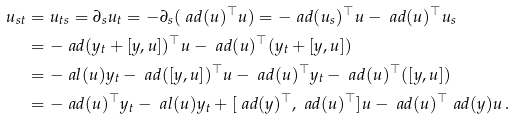<formula> <loc_0><loc_0><loc_500><loc_500>u _ { s t } & = u _ { t s } = \partial _ { s } u _ { t } = - \partial _ { s } ( \ a d ( u ) ^ { \top } u ) = - \ a d ( u _ { s } ) ^ { \top } u - \ a d ( u ) ^ { \top } u _ { s } \\ & = - \ a d ( y _ { t } + [ y , u ] ) ^ { \top } u - \ a d ( u ) ^ { \top } ( y _ { t } + [ y , u ] ) \\ & = - \ a l ( u ) y _ { t } - \ a d ( [ y , u ] ) ^ { \top } u - \ a d ( u ) ^ { \top } y _ { t } - \ a d ( u ) ^ { \top } ( [ y , u ] ) \\ & = - \ a d ( u ) ^ { \top } y _ { t } - \ a l ( u ) y _ { t } + [ \ a d ( y ) ^ { \top } , \ a d ( u ) ^ { \top } ] u - \ a d ( u ) ^ { \top } \ a d ( y ) u \, . \\</formula> 